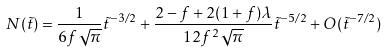Convert formula to latex. <formula><loc_0><loc_0><loc_500><loc_500>N ( \tilde { t } ) = \frac { 1 } { 6 f \sqrt { \pi } } \tilde { t } ^ { - 3 / 2 } + \frac { 2 - f + 2 ( 1 + f ) \lambda } { 1 2 f ^ { 2 } \sqrt { \pi } } \tilde { t } ^ { - 5 / 2 } + O ( \tilde { t } ^ { - 7 / 2 } )</formula> 